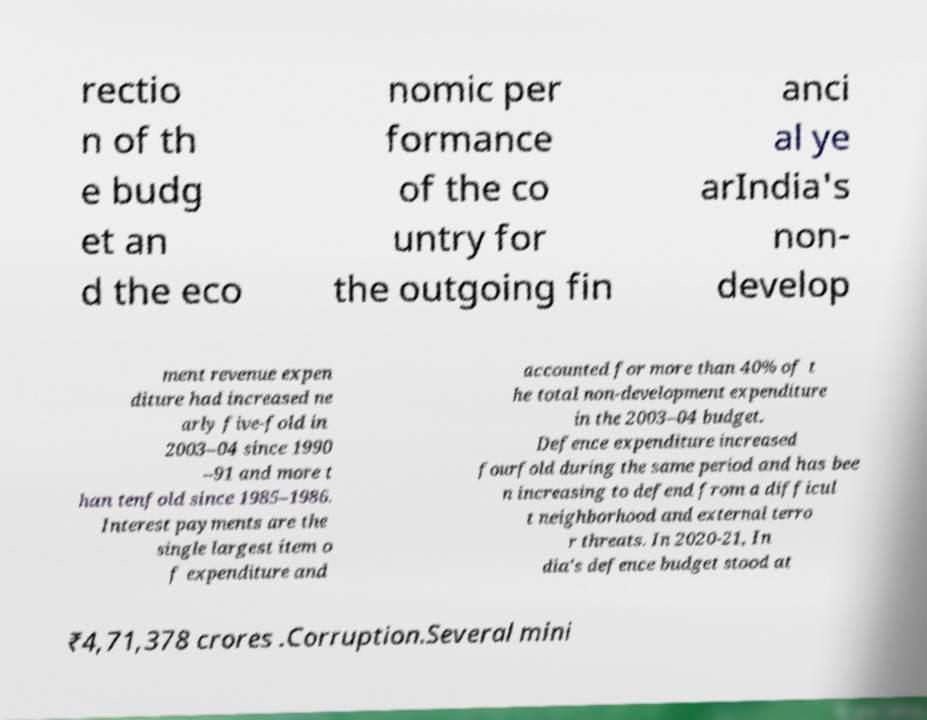I need the written content from this picture converted into text. Can you do that? rectio n of th e budg et an d the eco nomic per formance of the co untry for the outgoing fin anci al ye arIndia's non- develop ment revenue expen diture had increased ne arly five-fold in 2003–04 since 1990 –91 and more t han tenfold since 1985–1986. Interest payments are the single largest item o f expenditure and accounted for more than 40% of t he total non-development expenditure in the 2003–04 budget. Defence expenditure increased fourfold during the same period and has bee n increasing to defend from a difficul t neighborhood and external terro r threats. In 2020-21, In dia's defence budget stood at ₹4,71,378 crores .Corruption.Several mini 